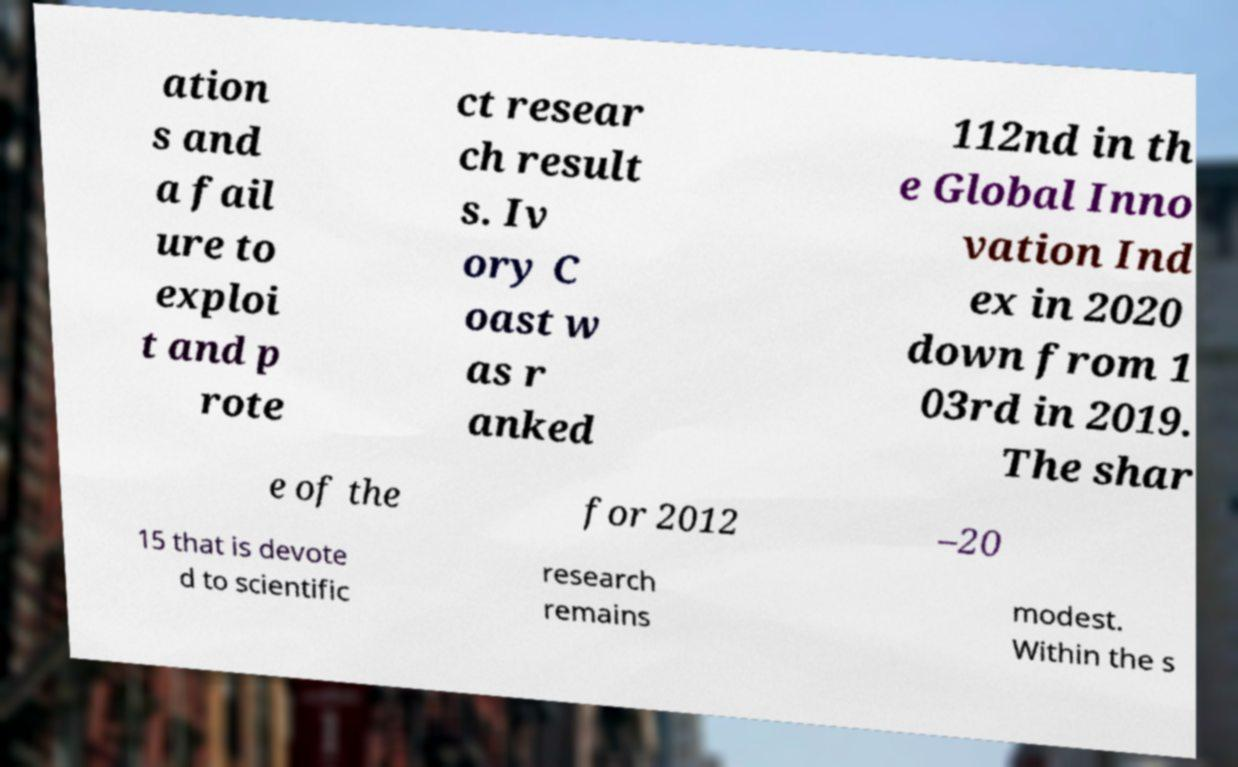Please read and relay the text visible in this image. What does it say? ation s and a fail ure to exploi t and p rote ct resear ch result s. Iv ory C oast w as r anked 112nd in th e Global Inno vation Ind ex in 2020 down from 1 03rd in 2019. The shar e of the for 2012 –20 15 that is devote d to scientific research remains modest. Within the s 